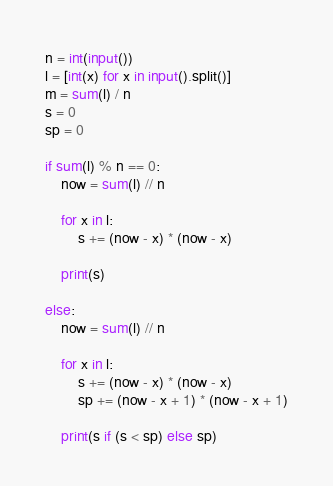Convert code to text. <code><loc_0><loc_0><loc_500><loc_500><_Python_>n = int(input())
l = [int(x) for x in input().split()]
m = sum(l) / n
s = 0
sp = 0

if sum(l) % n == 0:
    now = sum(l) // n

    for x in l:
        s += (now - x) * (now - x)

    print(s)
    
else:
    now = sum(l) // n

    for x in l:
        s += (now - x) * (now - x)
        sp += (now - x + 1) * (now - x + 1)

    print(s if (s < sp) else sp)</code> 